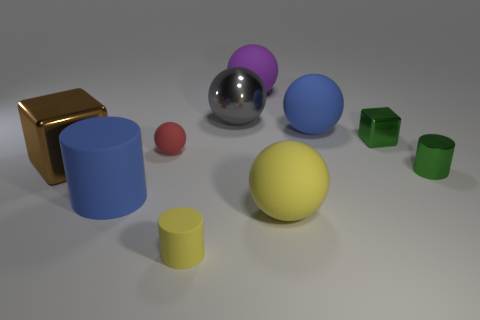Subtract all small rubber balls. How many balls are left? 4 Subtract 2 spheres. How many spheres are left? 3 Subtract all yellow balls. How many balls are left? 4 Add 1 green shiny objects. How many green shiny objects are left? 3 Add 3 tiny green metallic objects. How many tiny green metallic objects exist? 5 Subtract 1 green blocks. How many objects are left? 9 Subtract all cylinders. How many objects are left? 7 Subtract all brown blocks. Subtract all purple balls. How many blocks are left? 1 Subtract all cyan cubes. How many purple balls are left? 1 Subtract all large purple metallic things. Subtract all big brown blocks. How many objects are left? 9 